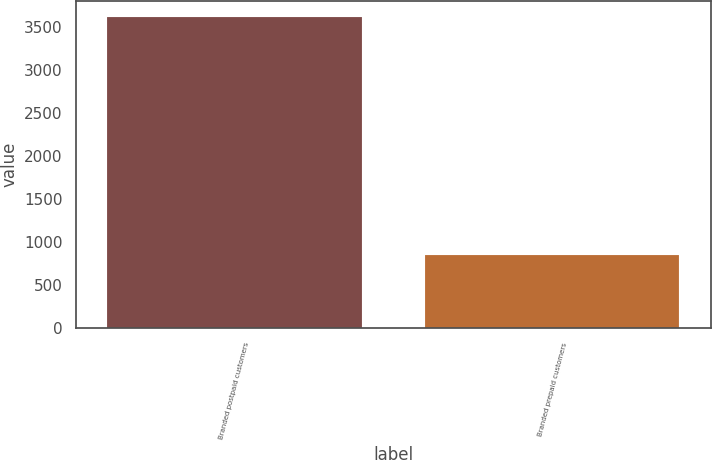Convert chart. <chart><loc_0><loc_0><loc_500><loc_500><bar_chart><fcel>Branded postpaid customers<fcel>Branded prepaid customers<nl><fcel>3620<fcel>855<nl></chart> 